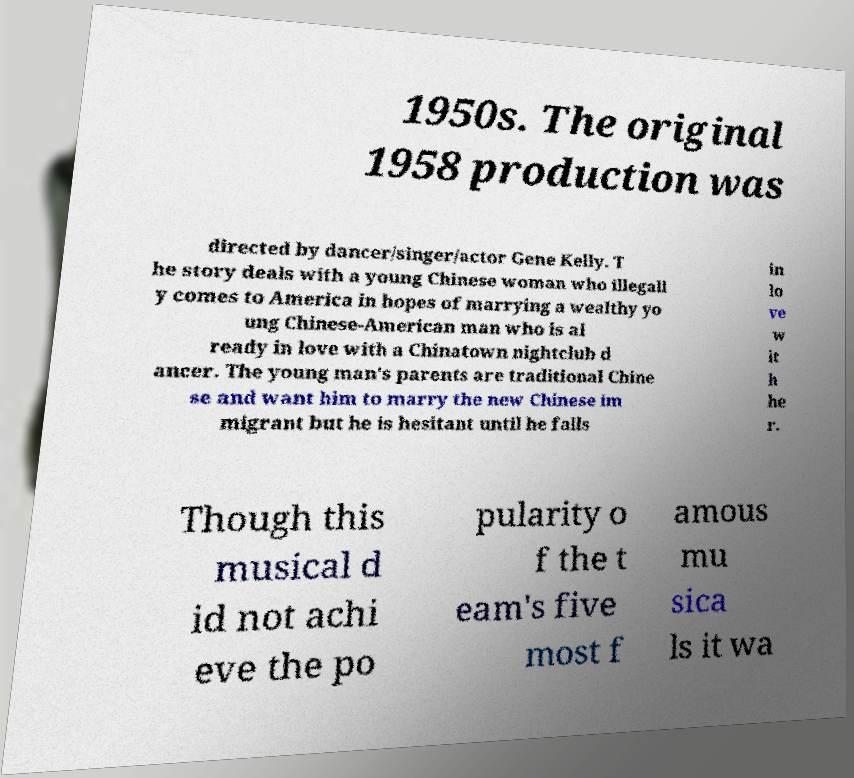What messages or text are displayed in this image? I need them in a readable, typed format. 1950s. The original 1958 production was directed by dancer/singer/actor Gene Kelly. T he story deals with a young Chinese woman who illegall y comes to America in hopes of marrying a wealthy yo ung Chinese-American man who is al ready in love with a Chinatown nightclub d ancer. The young man's parents are traditional Chine se and want him to marry the new Chinese im migrant but he is hesitant until he falls in lo ve w it h he r. Though this musical d id not achi eve the po pularity o f the t eam's five most f amous mu sica ls it wa 